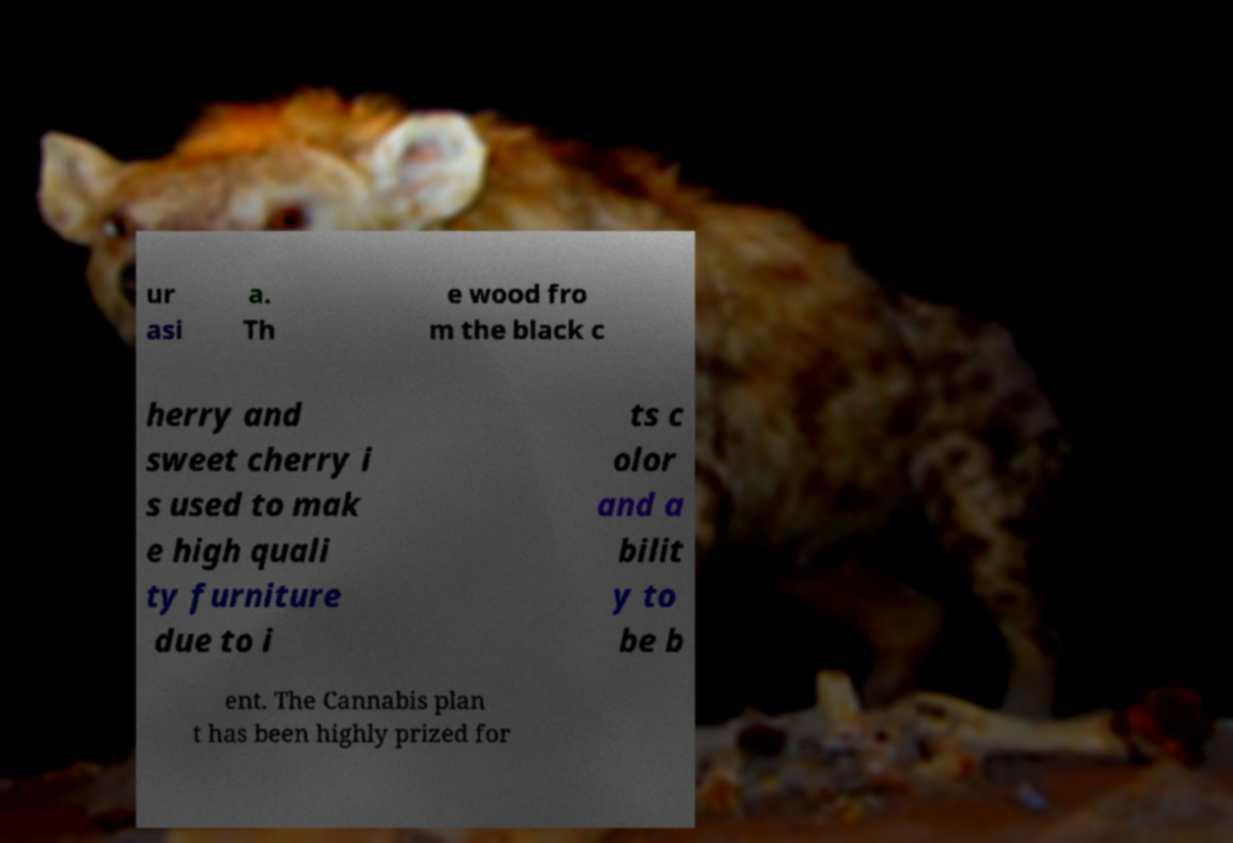Could you extract and type out the text from this image? ur asi a. Th e wood fro m the black c herry and sweet cherry i s used to mak e high quali ty furniture due to i ts c olor and a bilit y to be b ent. The Cannabis plan t has been highly prized for 